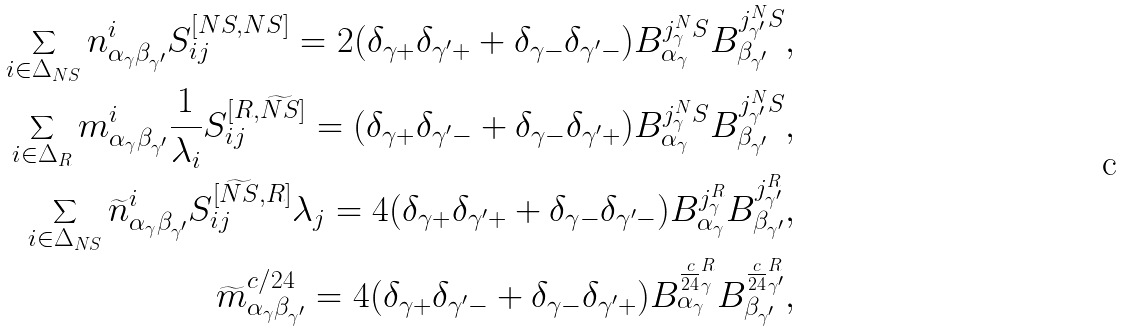<formula> <loc_0><loc_0><loc_500><loc_500>\sum _ { i \in \Delta _ { N S } } n ^ { i } _ { \alpha _ { \gamma } \beta _ { \gamma ^ { \prime } } } S ^ { [ N S , N S ] } _ { i j } = 2 ( \delta _ { \gamma + } \delta _ { \gamma ^ { \prime } + } + \delta _ { \gamma - } \delta _ { \gamma ^ { \prime } - } ) B _ { \alpha _ { \gamma } } ^ { j _ { \gamma } ^ { N } S } B _ { \beta _ { \gamma ^ { \prime } } } ^ { j _ { \gamma ^ { \prime } } ^ { N } S } & , \\ \sum _ { i \in \Delta _ { R } } m ^ { i } _ { \alpha _ { \gamma } \beta _ { \gamma ^ { \prime } } } \frac { 1 } { \lambda _ { i } } S ^ { [ R , \widetilde { N S } ] } _ { i j } = ( \delta _ { \gamma + } \delta _ { \gamma ^ { \prime } - } + \delta _ { \gamma - } \delta _ { \gamma ^ { \prime } + } ) B _ { \alpha _ { \gamma } } ^ { j _ { \gamma } ^ { N } S } B _ { \beta _ { \gamma ^ { \prime } } } ^ { j _ { \gamma ^ { \prime } } ^ { N } S } & , \\ \sum _ { i \in \Delta _ { N S } } \widetilde { n } ^ { i } _ { \alpha _ { \gamma } \beta _ { \gamma ^ { \prime } } } S ^ { [ \widetilde { N S } , R ] } _ { i j } \lambda _ { j } = 4 ( \delta _ { \gamma + } \delta _ { \gamma ^ { \prime } + } + \delta _ { \gamma - } \delta _ { \gamma ^ { \prime } - } ) B _ { \alpha _ { \gamma } } ^ { j _ { \gamma } ^ { R } } B _ { \beta _ { \gamma ^ { \prime } } } ^ { j _ { \gamma ^ { \prime } } ^ { R } } & , \\ \widetilde { m } ^ { c / 2 4 } _ { \alpha _ { \gamma } \beta _ { \gamma ^ { \prime } } } = 4 ( \delta _ { \gamma + } \delta _ { \gamma ^ { \prime } - } + \delta _ { \gamma - } \delta _ { \gamma ^ { \prime } + } ) B _ { \alpha _ { \gamma } } ^ { \frac { c } { 2 4 } _ { \gamma } ^ { R } } B _ { \beta _ { \gamma ^ { \prime } } } ^ { \frac { c } { 2 4 } _ { \gamma ^ { \prime } } ^ { R } } & ,</formula> 